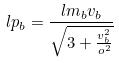Convert formula to latex. <formula><loc_0><loc_0><loc_500><loc_500>l p _ { b } = \frac { l m _ { b } v _ { b } } { \sqrt { 3 + \frac { v _ { b } ^ { 2 } } { o ^ { 2 } } } }</formula> 